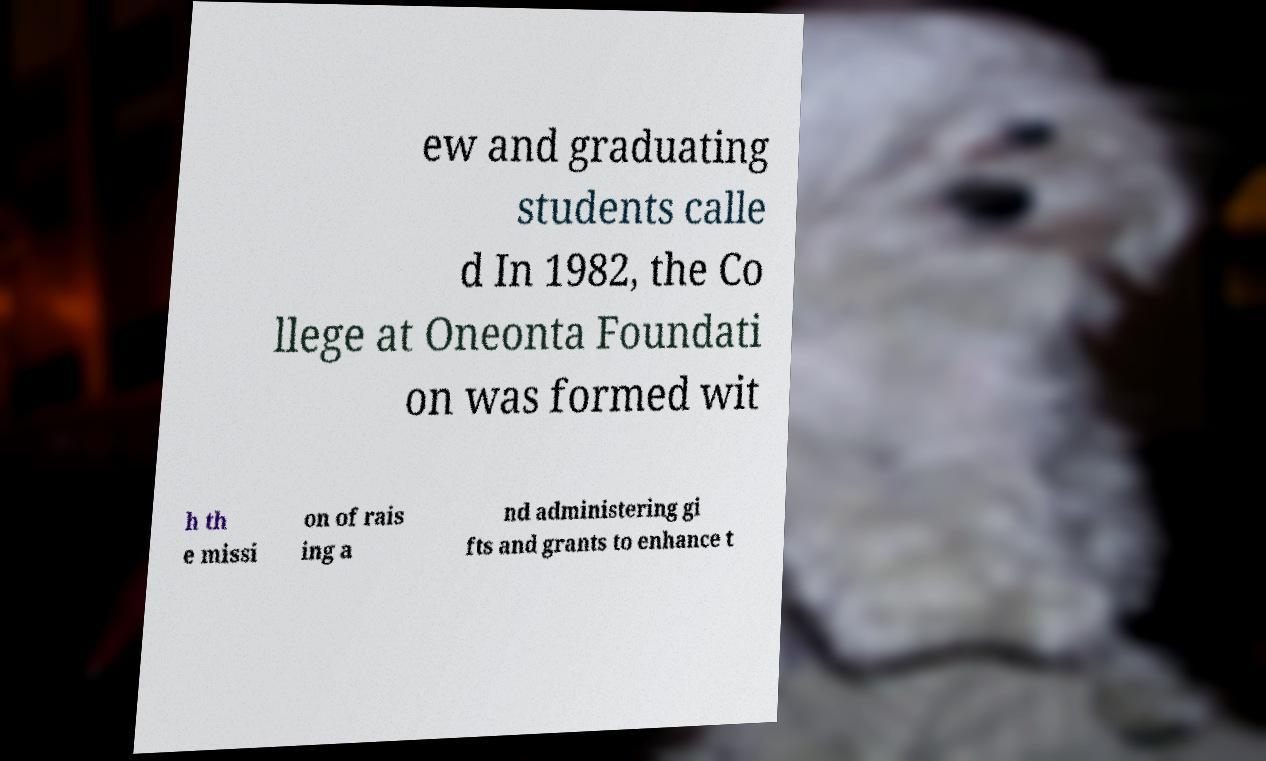Please read and relay the text visible in this image. What does it say? ew and graduating students calle d In 1982, the Co llege at Oneonta Foundati on was formed wit h th e missi on of rais ing a nd administering gi fts and grants to enhance t 